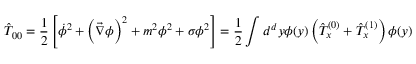Convert formula to latex. <formula><loc_0><loc_0><loc_500><loc_500>\hat { T } _ { 0 0 } = \frac { 1 } { 2 } \left [ \dot { \phi } ^ { 2 } + \left ( \vec { \nabla } \phi \right ) ^ { 2 } + m ^ { 2 } \phi ^ { 2 } + \sigma \phi ^ { 2 } \right ] = \frac { 1 } { 2 } \int d ^ { d } y \phi ( y ) \left ( \hat { T } _ { x } ^ { ( 0 ) } + \hat { T } _ { x } ^ { ( 1 ) } \right ) \phi ( y )</formula> 